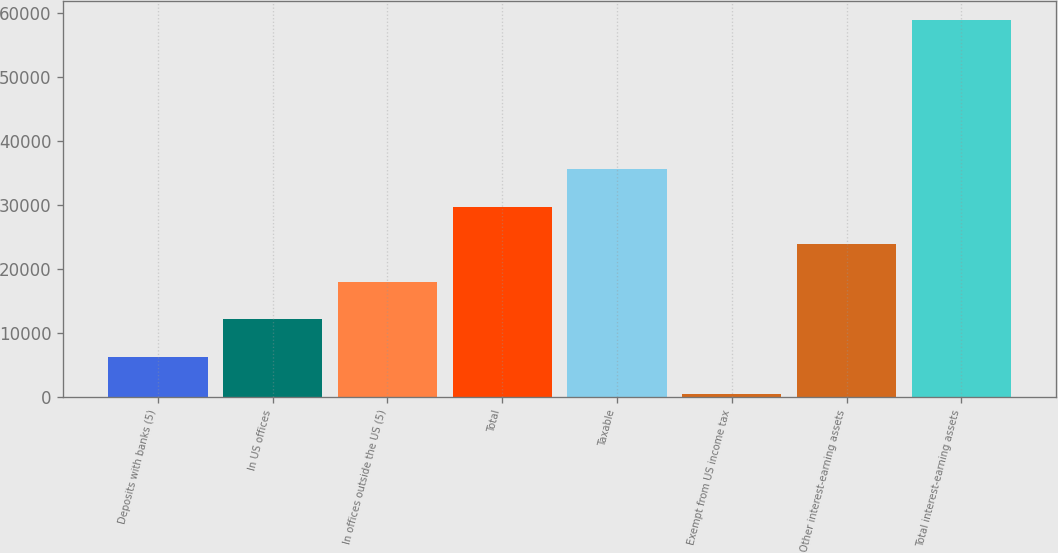Convert chart. <chart><loc_0><loc_0><loc_500><loc_500><bar_chart><fcel>Deposits with banks (5)<fcel>In US offices<fcel>In offices outside the US (5)<fcel>Total<fcel>Taxable<fcel>Exempt from US income tax<fcel>Other interest-earning assets<fcel>Total interest-earning assets<nl><fcel>6302.7<fcel>12162.4<fcel>18022.1<fcel>29741.5<fcel>35601.2<fcel>443<fcel>23881.8<fcel>59040<nl></chart> 